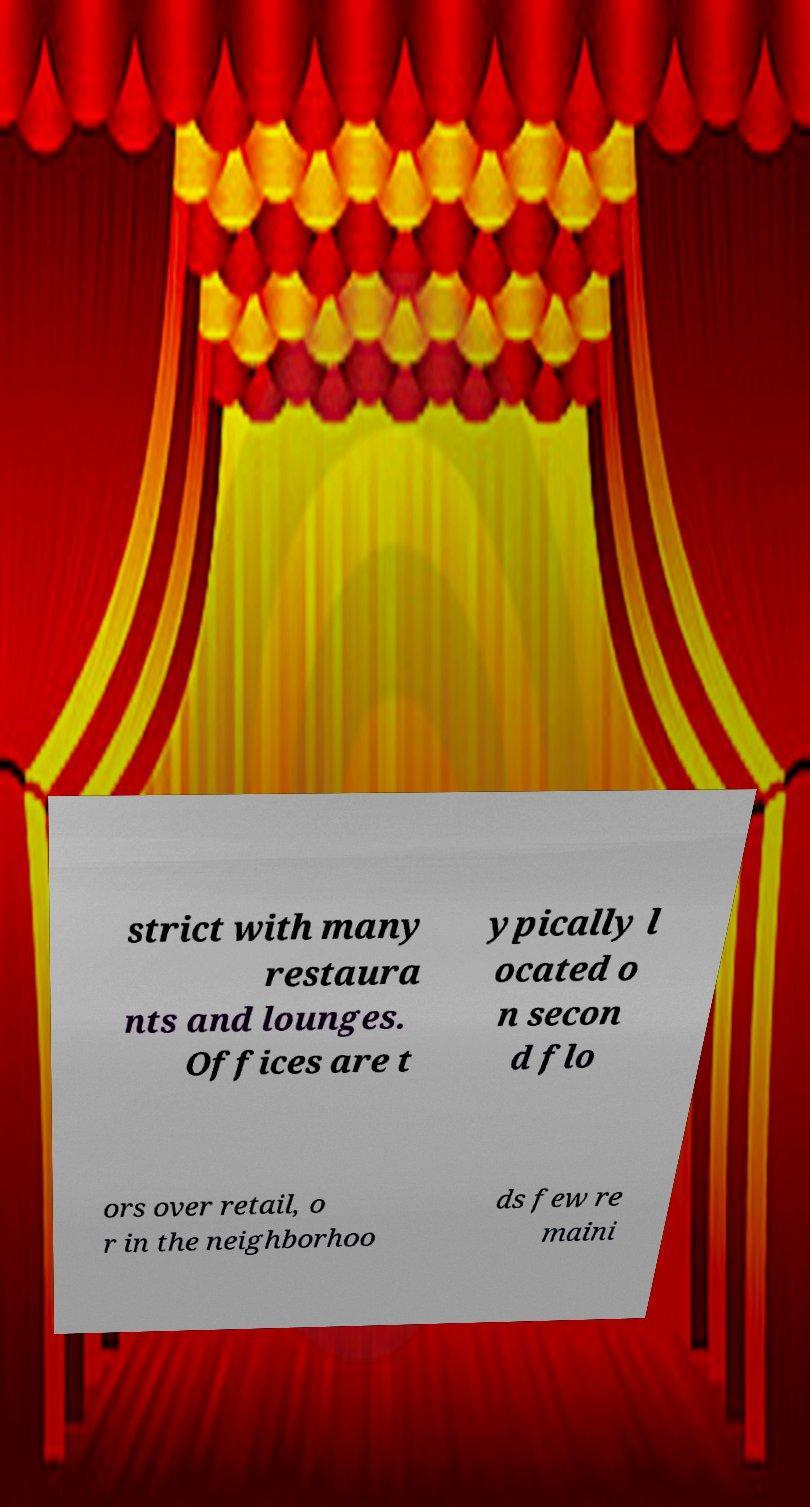What messages or text are displayed in this image? I need them in a readable, typed format. strict with many restaura nts and lounges. Offices are t ypically l ocated o n secon d flo ors over retail, o r in the neighborhoo ds few re maini 